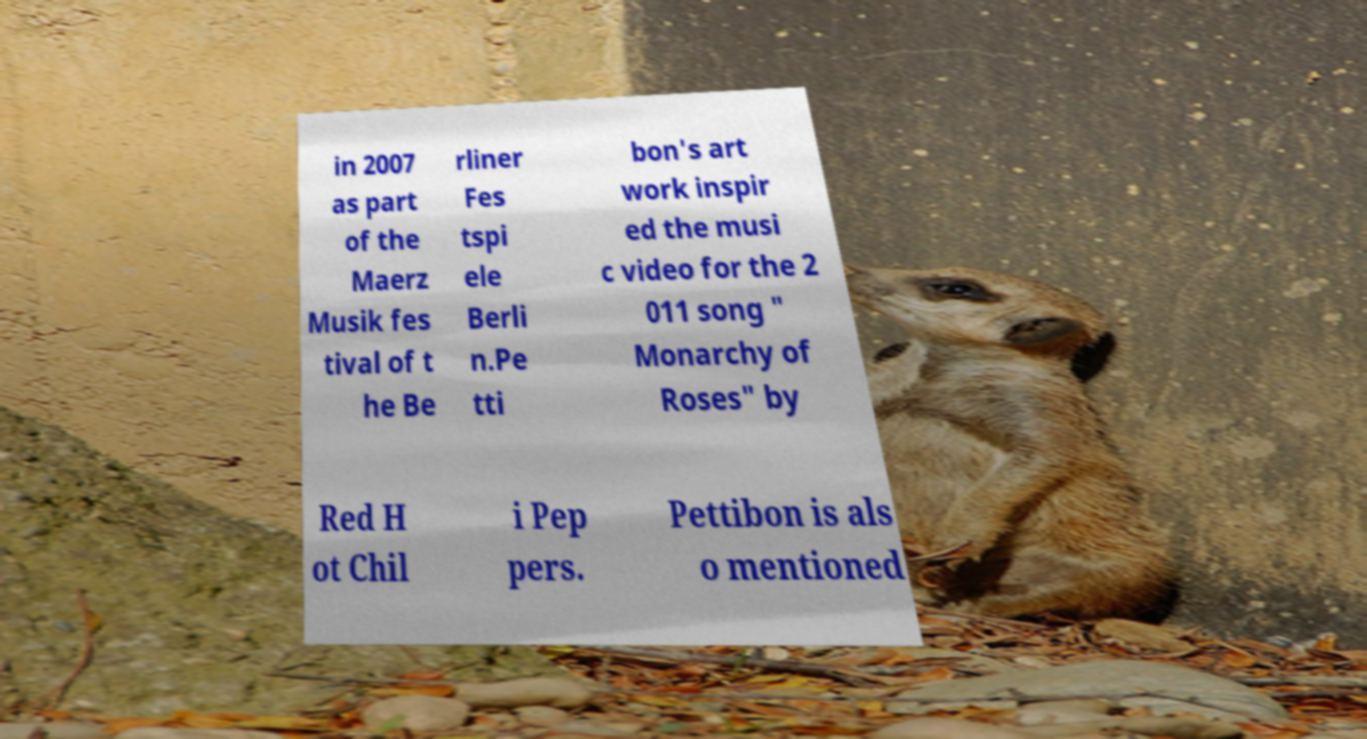For documentation purposes, I need the text within this image transcribed. Could you provide that? in 2007 as part of the Maerz Musik fes tival of t he Be rliner Fes tspi ele Berli n.Pe tti bon's art work inspir ed the musi c video for the 2 011 song " Monarchy of Roses" by Red H ot Chil i Pep pers. Pettibon is als o mentioned 